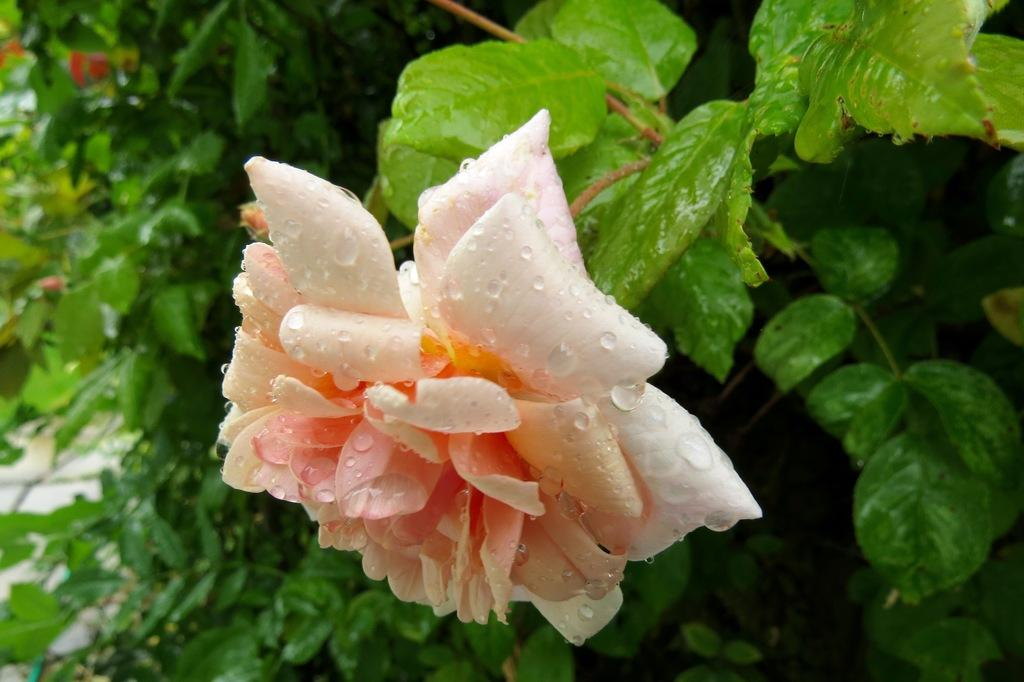What is the main subject in the middle of the image? There is a flower in the middle of the image. What else can be seen in the background of the image? There are plants visible behind the flower. What type of advertisement is being taught in the image? There is no advertisement or teaching activity present in the image; it features a flower and plants. What sound can be heard coming from the bells in the image? There are no bells present in the image, so no sound can be heard. 